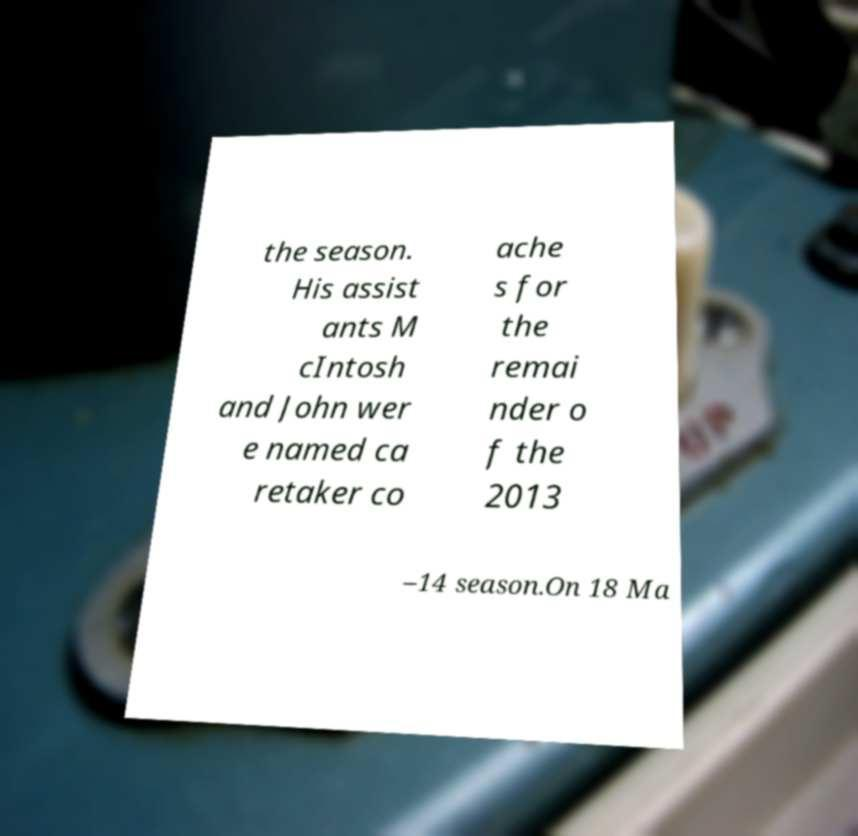Please read and relay the text visible in this image. What does it say? the season. His assist ants M cIntosh and John wer e named ca retaker co ache s for the remai nder o f the 2013 –14 season.On 18 Ma 